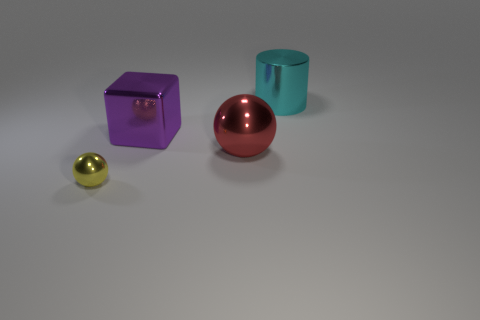There is a sphere right of the shiny thing in front of the big object in front of the big purple object; what is its material?
Ensure brevity in your answer.  Metal. Is the number of yellow things that are to the left of the cyan thing the same as the number of large purple rubber blocks?
Provide a succinct answer. No. Are there any other things that are the same size as the cyan metal cylinder?
Your answer should be compact. Yes. What number of objects are either tiny yellow metal balls or big purple metal cubes?
Make the answer very short. 2. What shape is the big cyan object that is made of the same material as the big block?
Ensure brevity in your answer.  Cylinder. How big is the metal sphere that is behind the metallic thing in front of the large red thing?
Provide a succinct answer. Large. How many small objects are matte objects or purple things?
Make the answer very short. 0. How many other objects are the same color as the large shiny cylinder?
Your answer should be very brief. 0. There is a metallic ball right of the yellow object; is it the same size as the shiny thing that is in front of the big red metal ball?
Provide a succinct answer. No. Is the number of objects on the right side of the yellow object greater than the number of tiny metallic spheres that are behind the cyan metallic cylinder?
Keep it short and to the point. Yes. 